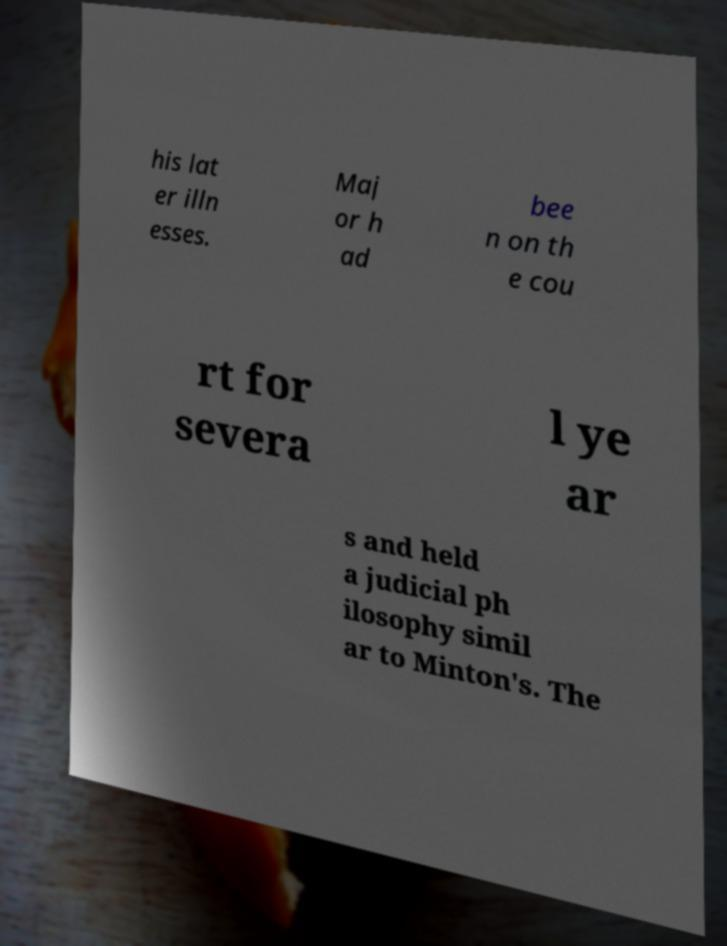Could you extract and type out the text from this image? his lat er illn esses. Maj or h ad bee n on th e cou rt for severa l ye ar s and held a judicial ph ilosophy simil ar to Minton's. The 